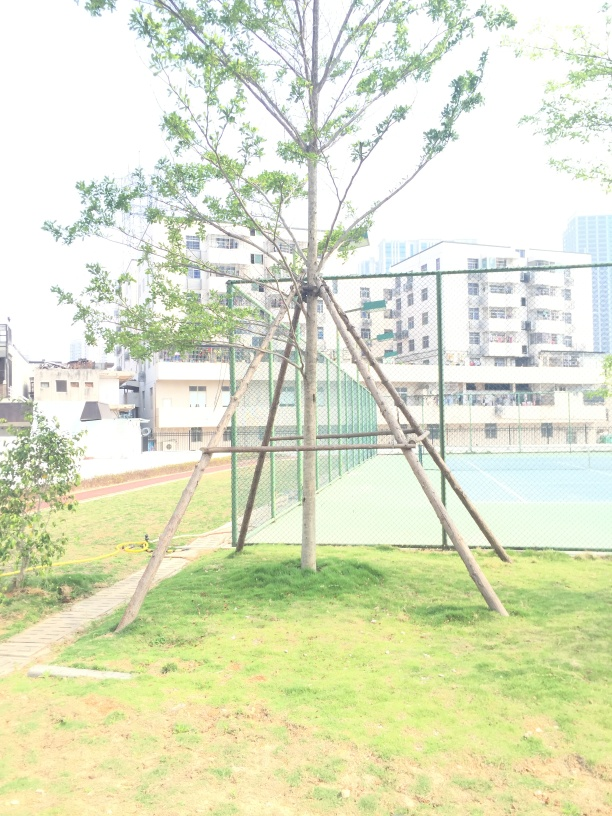Does the environment seem well-maintained? Yes, the grass looks recently mowed, and the tree is supported by a well-constructed framework, suggesting regular upkeep. The recreational equipment, such as the tennis courts, also appears to be in good condition, all of which imply diligent maintenance. 